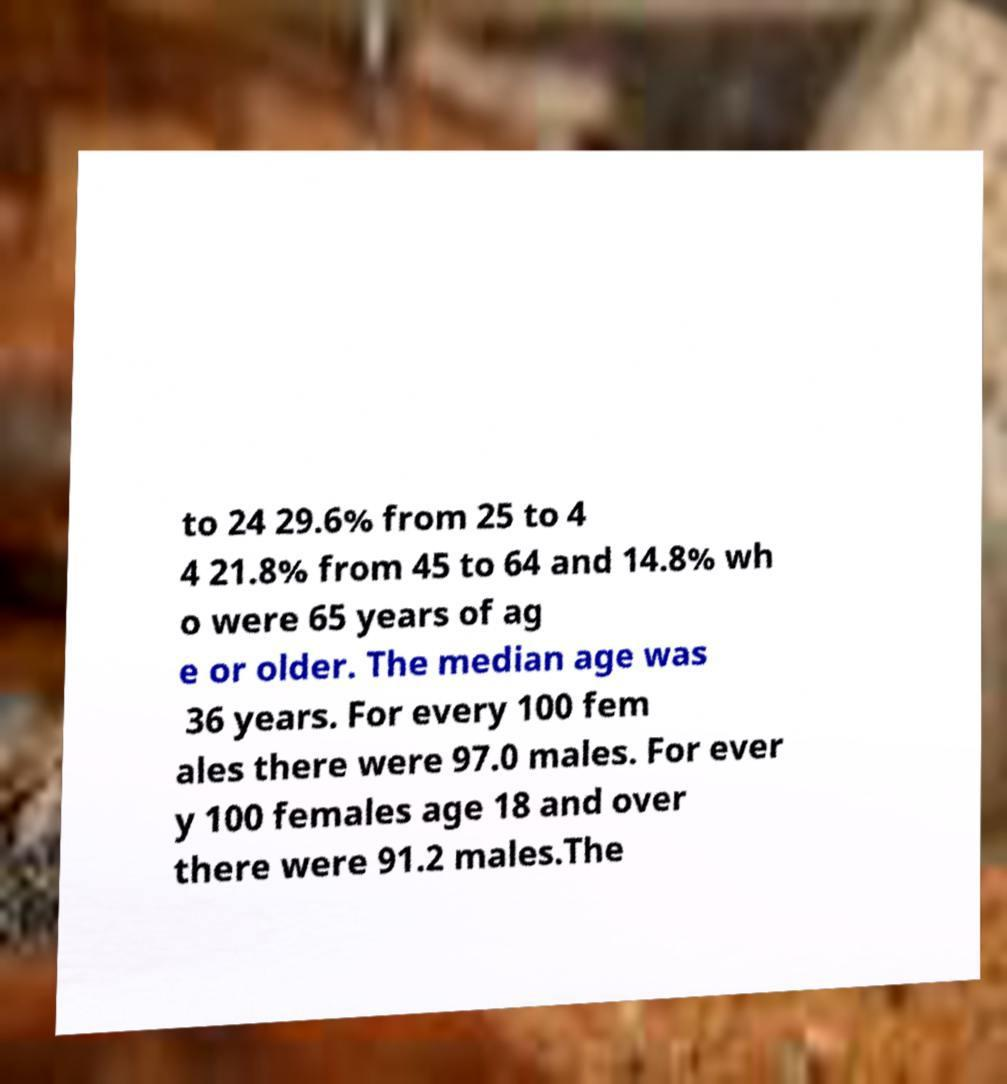There's text embedded in this image that I need extracted. Can you transcribe it verbatim? to 24 29.6% from 25 to 4 4 21.8% from 45 to 64 and 14.8% wh o were 65 years of ag e or older. The median age was 36 years. For every 100 fem ales there were 97.0 males. For ever y 100 females age 18 and over there were 91.2 males.The 